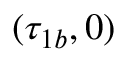Convert formula to latex. <formula><loc_0><loc_0><loc_500><loc_500>( \tau _ { 1 b } , 0 )</formula> 